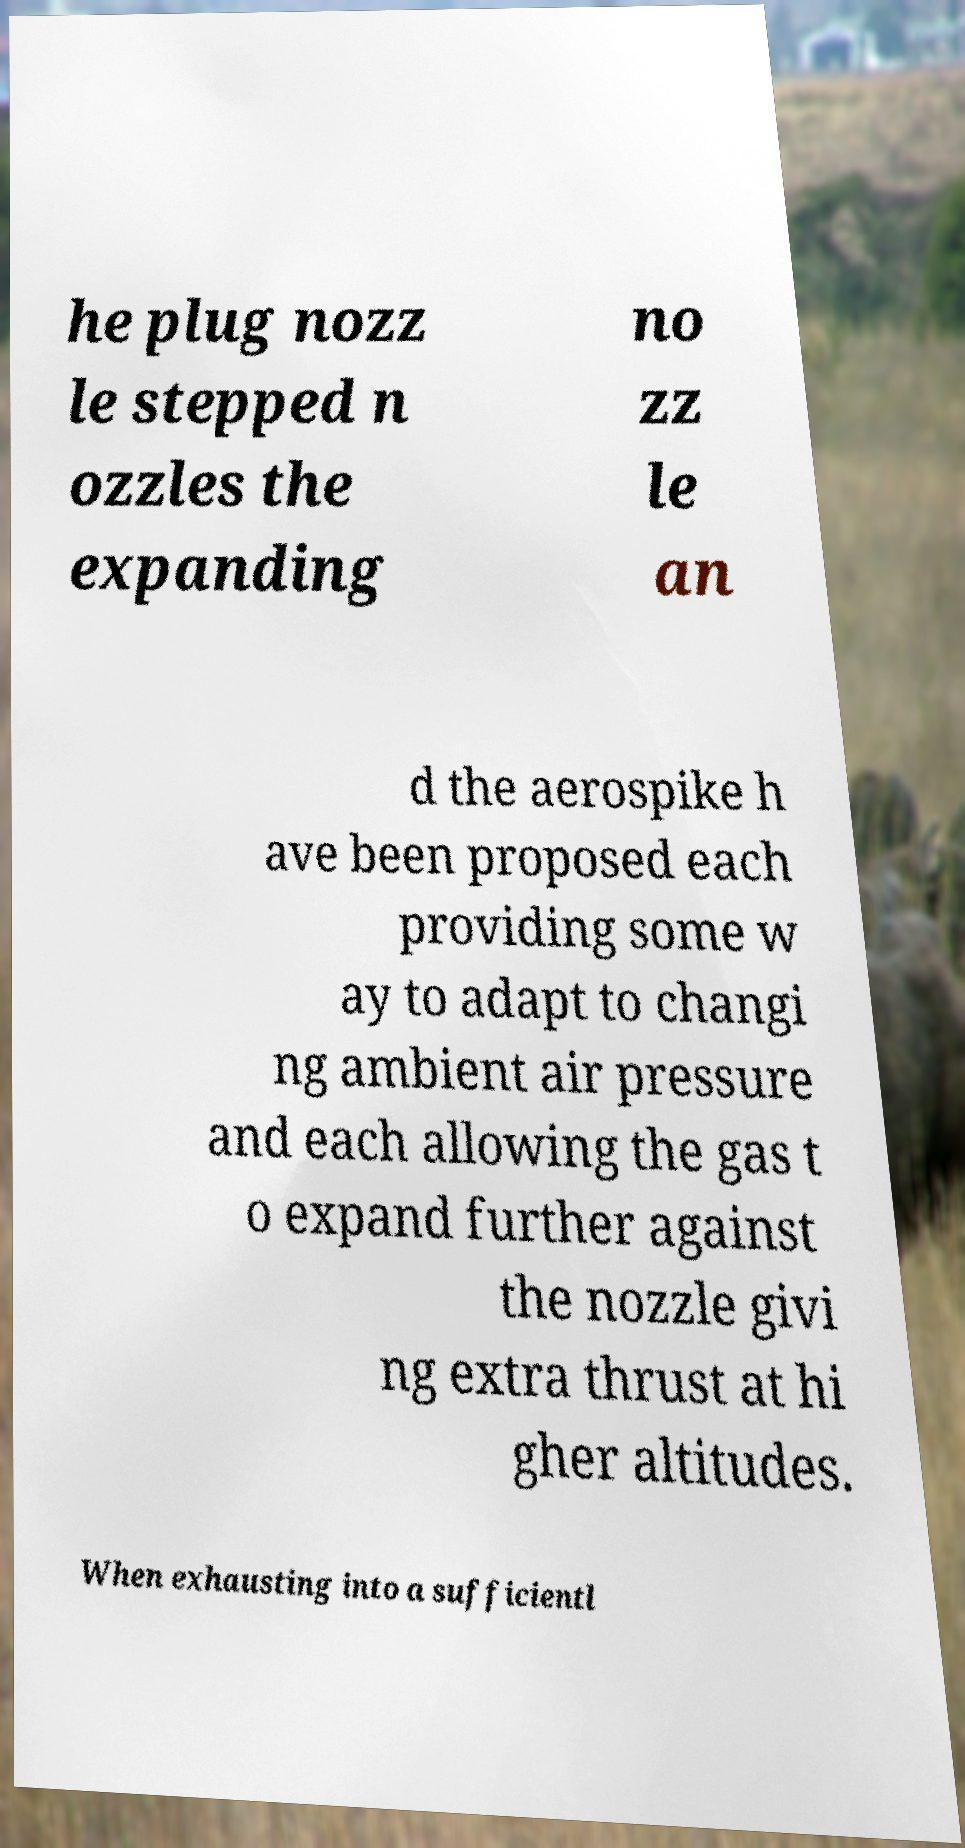What messages or text are displayed in this image? I need them in a readable, typed format. he plug nozz le stepped n ozzles the expanding no zz le an d the aerospike h ave been proposed each providing some w ay to adapt to changi ng ambient air pressure and each allowing the gas t o expand further against the nozzle givi ng extra thrust at hi gher altitudes. When exhausting into a sufficientl 